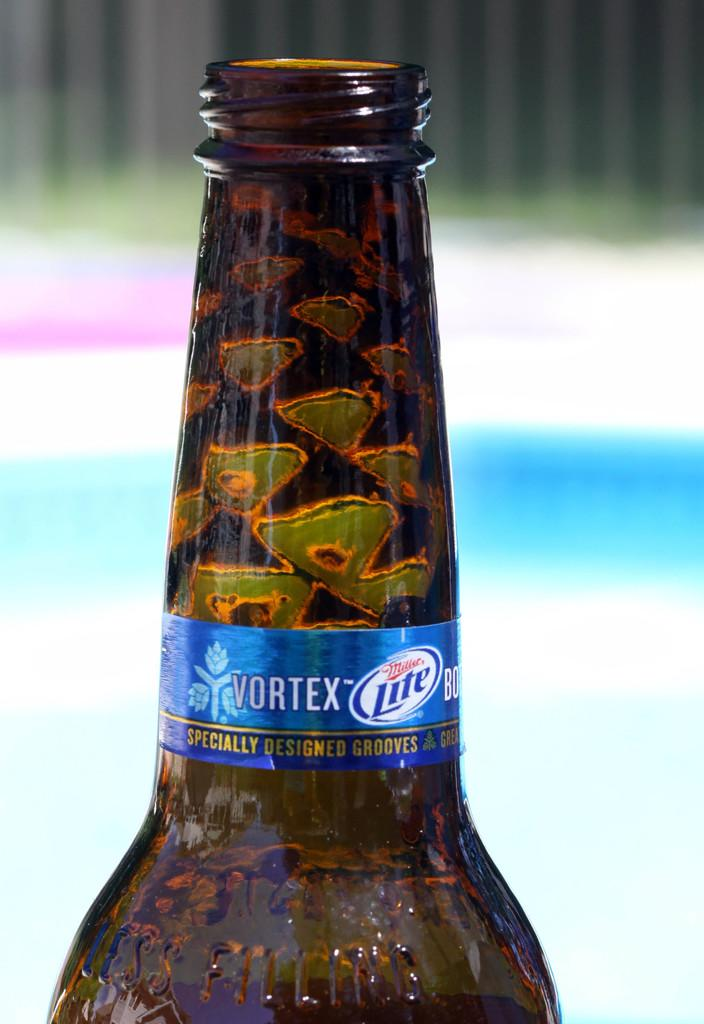<image>
Share a concise interpretation of the image provided. A close up of a Miller Lite beer bottle. 